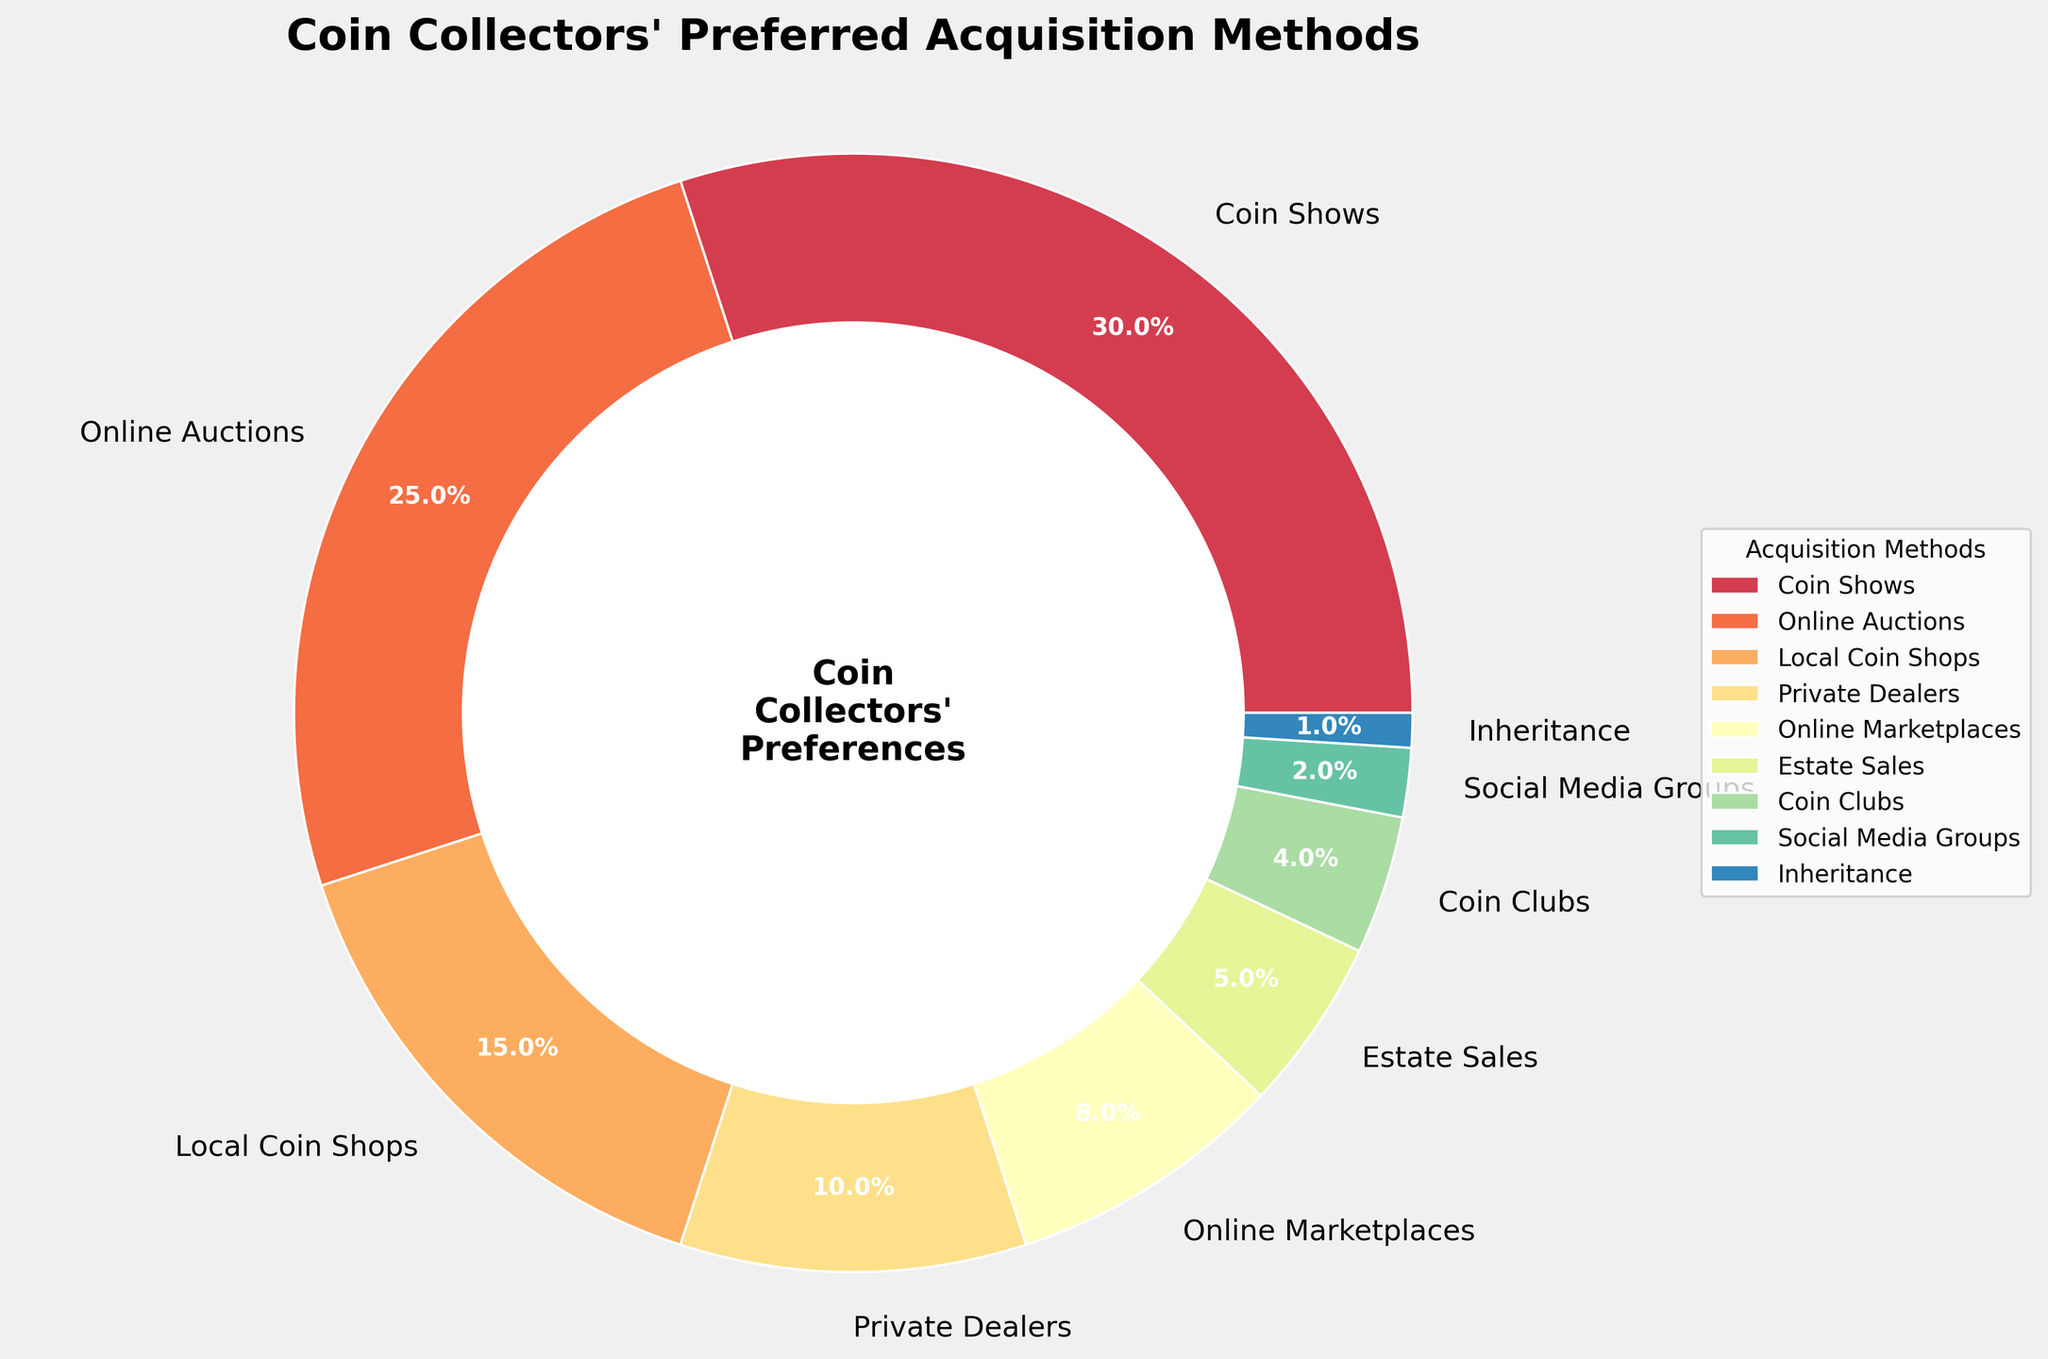Which acquisition method is preferred by the highest percentage of coin collectors? The wedge representing "Coin Shows" appears largest at 30%, indicating it is the most preferred method.
Answer: Coin Shows Which two methods have the smallest percentages? By comparing the sizes of the wedges, "Inheritance" at 1% and "Social Media Groups" at 2% are the smallest.
Answer: Inheritance, Social Media Groups What is the combined percentage of collectors who prefer Online Auctions and Online Marketplaces? The wedge for "Online Auctions" is 25% and for "Online Marketplaces" is 8%, so their combined percentage is 25% + 8% = 33%.
Answer: 33% How much more preferred is attending Coin Shows compared to purchasing from Local Coin Shops? The percentage for "Coin Shows" is 30% and for "Local Coin Shops" is 15%, thus "Coin Shows" is preferred by 30% - 15% = 15% more.
Answer: 15% Which category's wedge is orange in color? The orange color wedge represents "Local Coin Shops" as seen from the color distribution in the chart.
Answer: Local Coin Shops Which two methods together account for exactly 25% of coin collectors' preferences? The smaller wedges need to be considered together; "Estate Sales" at 5% and "Coin Clubs" at 4% combined are 9%, then adding "Social Media Groups" at 2% leads to 11%, and adding "Private Dealers" at 10% gives 21%. Finally, including "Inheritance" at 1% gives 22%. Continue until precise matches are found: "Online Marketplaces" at 8% and "Estate Sales" at 5% are 13% plus "Coin Clubs" at 4% equals 17%, adding "Social Media Groups" at 2% leads to 19%, the inclusion of "Inheritance" at 1% results in only 20%. Hence only through larger method inclusion does 25% derive from "Social Media Groups" 15% + "Private Dealers" 10%. Other approach: analysis of "Online Auctions" one of {top 2 in percentage 25%together}. Thus 30% for highest "Coin Shows" versus 25% of "Online Auctions".
Answer: Online Auctions, Local Coin Shops, Private Dealers, Estate Sales, Coin Clubs, Social Media Groups, Inheritance Other cumulative recombinations yield none diversely paired individuation to exactly the same 25% Which is less preferred: Private Dealers or Estate Sales? Comparing the wedges, Estate Sales at 5% is less preferred than Private Dealers at 10%.
Answer: Estate Sales 